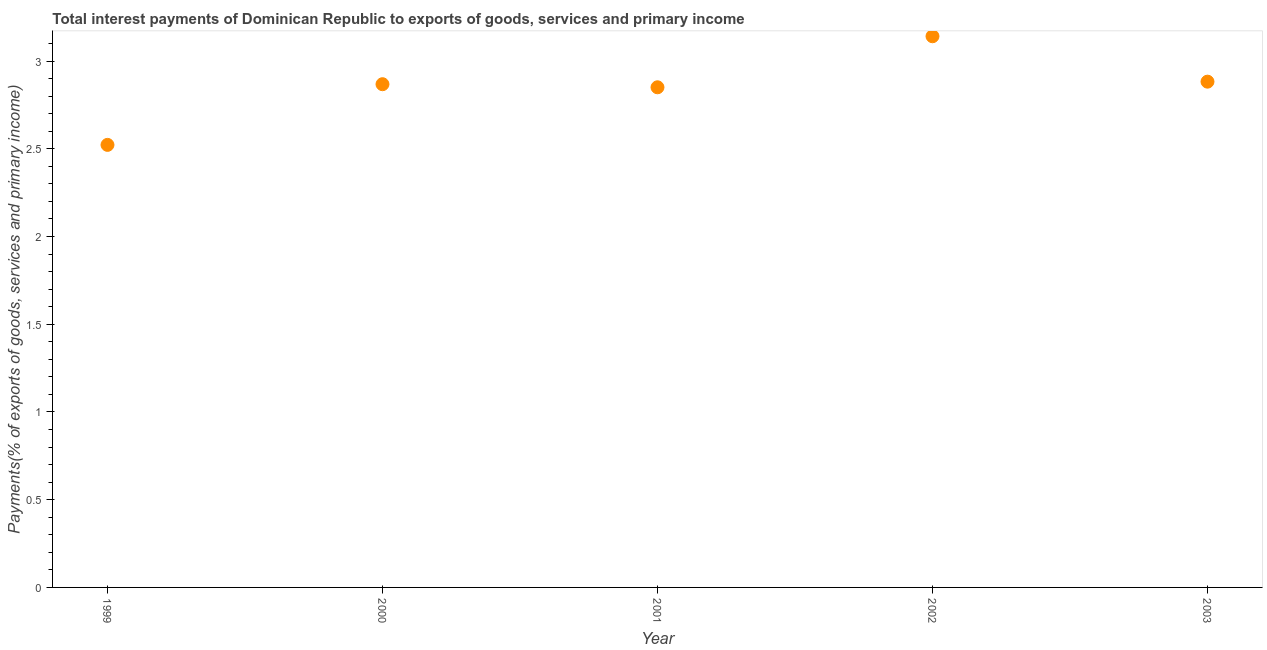What is the total interest payments on external debt in 1999?
Give a very brief answer. 2.52. Across all years, what is the maximum total interest payments on external debt?
Ensure brevity in your answer.  3.14. Across all years, what is the minimum total interest payments on external debt?
Provide a succinct answer. 2.52. In which year was the total interest payments on external debt maximum?
Give a very brief answer. 2002. In which year was the total interest payments on external debt minimum?
Offer a terse response. 1999. What is the sum of the total interest payments on external debt?
Your response must be concise. 14.26. What is the difference between the total interest payments on external debt in 1999 and 2001?
Your response must be concise. -0.33. What is the average total interest payments on external debt per year?
Provide a short and direct response. 2.85. What is the median total interest payments on external debt?
Provide a short and direct response. 2.87. What is the ratio of the total interest payments on external debt in 2001 to that in 2002?
Your answer should be very brief. 0.91. Is the total interest payments on external debt in 1999 less than that in 2003?
Offer a terse response. Yes. What is the difference between the highest and the second highest total interest payments on external debt?
Keep it short and to the point. 0.26. What is the difference between the highest and the lowest total interest payments on external debt?
Your response must be concise. 0.62. In how many years, is the total interest payments on external debt greater than the average total interest payments on external debt taken over all years?
Keep it short and to the point. 3. Does the total interest payments on external debt monotonically increase over the years?
Offer a terse response. No. How many dotlines are there?
Offer a very short reply. 1. How many years are there in the graph?
Provide a short and direct response. 5. What is the difference between two consecutive major ticks on the Y-axis?
Your response must be concise. 0.5. Does the graph contain grids?
Provide a succinct answer. No. What is the title of the graph?
Keep it short and to the point. Total interest payments of Dominican Republic to exports of goods, services and primary income. What is the label or title of the Y-axis?
Your answer should be very brief. Payments(% of exports of goods, services and primary income). What is the Payments(% of exports of goods, services and primary income) in 1999?
Your answer should be very brief. 2.52. What is the Payments(% of exports of goods, services and primary income) in 2000?
Offer a very short reply. 2.87. What is the Payments(% of exports of goods, services and primary income) in 2001?
Make the answer very short. 2.85. What is the Payments(% of exports of goods, services and primary income) in 2002?
Offer a terse response. 3.14. What is the Payments(% of exports of goods, services and primary income) in 2003?
Ensure brevity in your answer.  2.88. What is the difference between the Payments(% of exports of goods, services and primary income) in 1999 and 2000?
Your answer should be very brief. -0.35. What is the difference between the Payments(% of exports of goods, services and primary income) in 1999 and 2001?
Provide a succinct answer. -0.33. What is the difference between the Payments(% of exports of goods, services and primary income) in 1999 and 2002?
Provide a succinct answer. -0.62. What is the difference between the Payments(% of exports of goods, services and primary income) in 1999 and 2003?
Give a very brief answer. -0.36. What is the difference between the Payments(% of exports of goods, services and primary income) in 2000 and 2001?
Keep it short and to the point. 0.02. What is the difference between the Payments(% of exports of goods, services and primary income) in 2000 and 2002?
Ensure brevity in your answer.  -0.27. What is the difference between the Payments(% of exports of goods, services and primary income) in 2000 and 2003?
Offer a terse response. -0.01. What is the difference between the Payments(% of exports of goods, services and primary income) in 2001 and 2002?
Provide a short and direct response. -0.29. What is the difference between the Payments(% of exports of goods, services and primary income) in 2001 and 2003?
Offer a very short reply. -0.03. What is the difference between the Payments(% of exports of goods, services and primary income) in 2002 and 2003?
Your response must be concise. 0.26. What is the ratio of the Payments(% of exports of goods, services and primary income) in 1999 to that in 2000?
Provide a short and direct response. 0.88. What is the ratio of the Payments(% of exports of goods, services and primary income) in 1999 to that in 2001?
Your answer should be very brief. 0.89. What is the ratio of the Payments(% of exports of goods, services and primary income) in 1999 to that in 2002?
Your answer should be compact. 0.8. What is the ratio of the Payments(% of exports of goods, services and primary income) in 2001 to that in 2002?
Your answer should be very brief. 0.91. What is the ratio of the Payments(% of exports of goods, services and primary income) in 2001 to that in 2003?
Offer a very short reply. 0.99. What is the ratio of the Payments(% of exports of goods, services and primary income) in 2002 to that in 2003?
Make the answer very short. 1.09. 